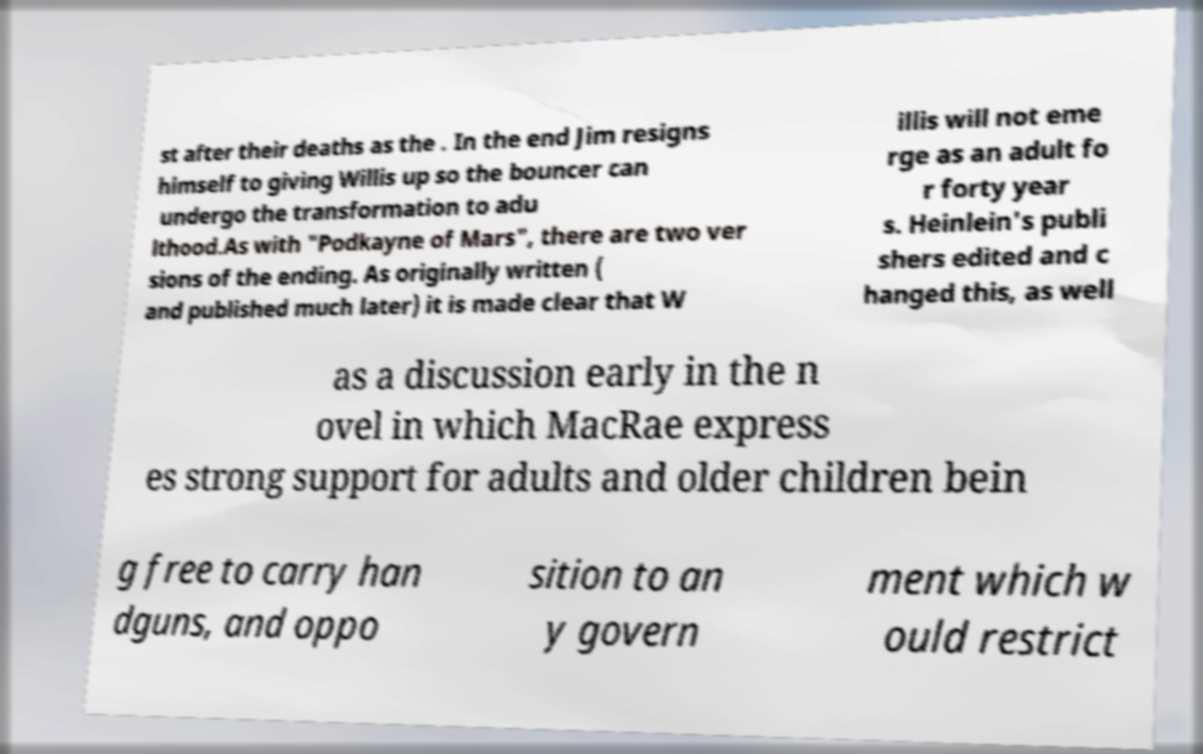Can you accurately transcribe the text from the provided image for me? st after their deaths as the . In the end Jim resigns himself to giving Willis up so the bouncer can undergo the transformation to adu lthood.As with "Podkayne of Mars", there are two ver sions of the ending. As originally written ( and published much later) it is made clear that W illis will not eme rge as an adult fo r forty year s. Heinlein's publi shers edited and c hanged this, as well as a discussion early in the n ovel in which MacRae express es strong support for adults and older children bein g free to carry han dguns, and oppo sition to an y govern ment which w ould restrict 